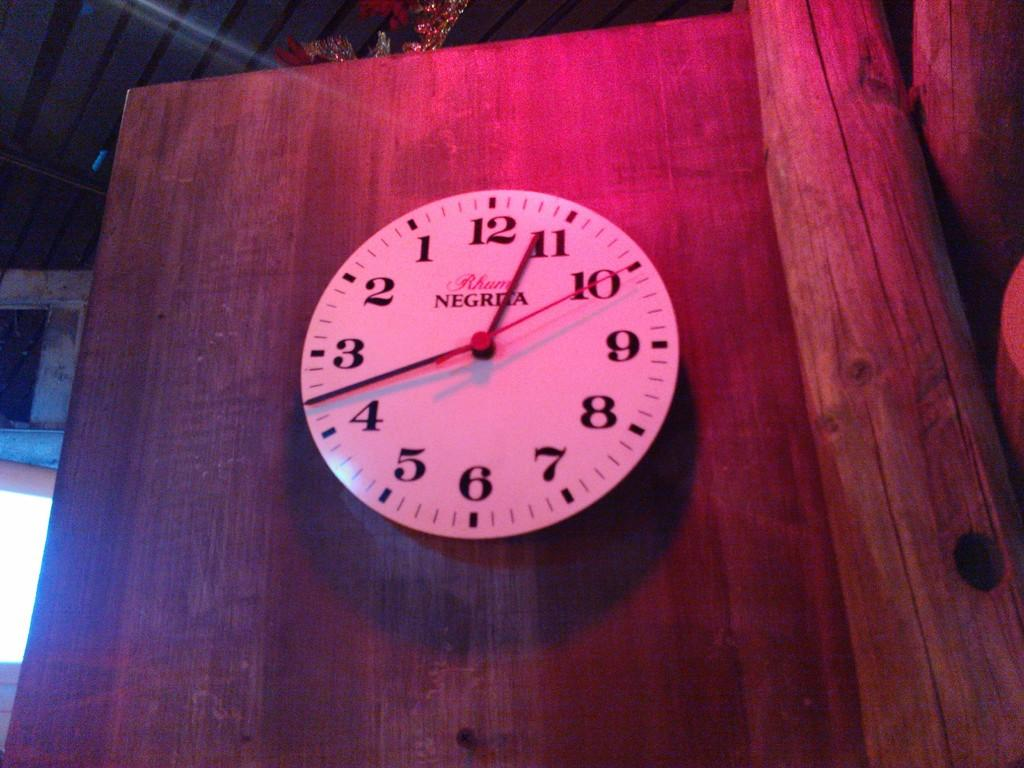What is the main object in the picture? There is a clock in the picture. What is the clock attached to? The clock is attached to a wooden object. Are there any other objects visible in the image? Yes, there are other objects in the left and right corners of the image. What type of kettle is used to boil water in the image? There is no kettle present in the image. What station is the clock connected to in the image? The clock is not connected to a station in the image; it is attached to a wooden object. 